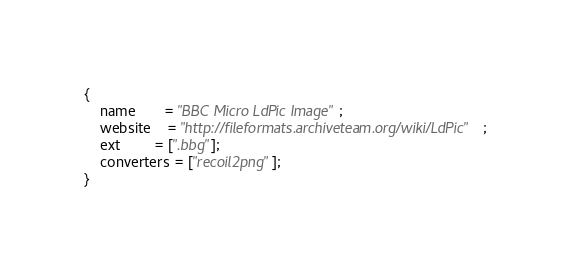Convert code to text. <code><loc_0><loc_0><loc_500><loc_500><_JavaScript_>{
	name       = "BBC Micro LdPic Image";
	website    = "http://fileformats.archiveteam.org/wiki/LdPic";
	ext        = [".bbg"];
	converters = ["recoil2png"];
}
</code> 